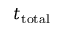Convert formula to latex. <formula><loc_0><loc_0><loc_500><loc_500>t _ { t o t a l }</formula> 